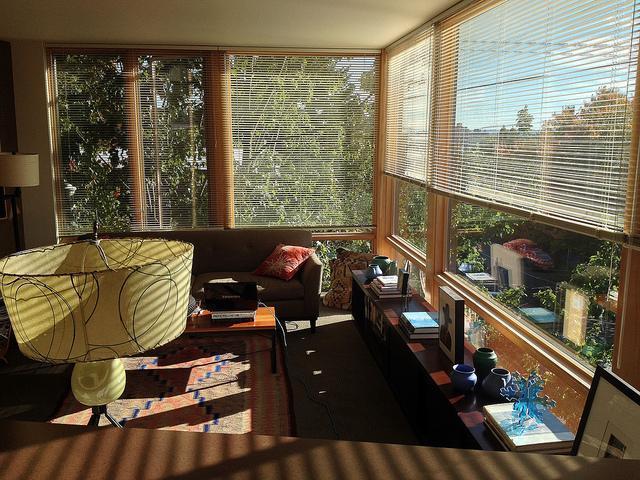How many items in the living room may have to share an outlet with the laptop?
Pick the correct solution from the four options below to address the question.
Options: Five, three, two, four. Two. 